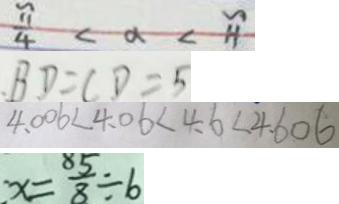Convert formula to latex. <formula><loc_0><loc_0><loc_500><loc_500>\frac { \pi } { 4 } < \alpha < \pi 
 B D = C D = 5 
 4 . 0 0 6 < 4 . 0 6 < 4 . 6 < 4 . 6 0 6 
 x = \frac { 5 } { 8 } \div 6</formula> 